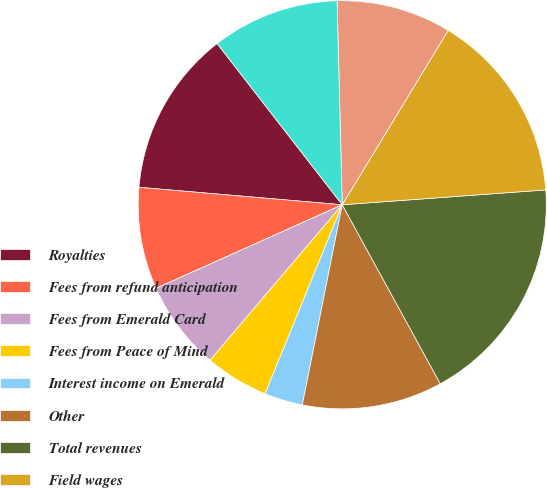Convert chart to OTSL. <chart><loc_0><loc_0><loc_500><loc_500><pie_chart><fcel>Royalties<fcel>Fees from refund anticipation<fcel>Fees from Emerald Card<fcel>Fees from Peace of Mind<fcel>Interest income on Emerald<fcel>Other<fcel>Total revenues<fcel>Field wages<fcel>Other wages<fcel>Benefits and other<nl><fcel>13.13%<fcel>8.08%<fcel>7.07%<fcel>5.05%<fcel>3.03%<fcel>11.11%<fcel>18.18%<fcel>15.15%<fcel>9.09%<fcel>10.1%<nl></chart> 